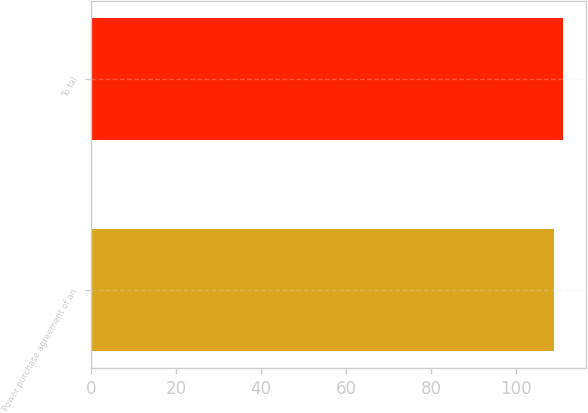Convert chart. <chart><loc_0><loc_0><loc_500><loc_500><bar_chart><fcel>Power purchase agreement of an<fcel>To tal<nl><fcel>109<fcel>111<nl></chart> 